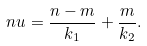Convert formula to latex. <formula><loc_0><loc_0><loc_500><loc_500>\ n u = \frac { n - m } { k _ { 1 } } + \frac { m } { k _ { 2 } } .</formula> 